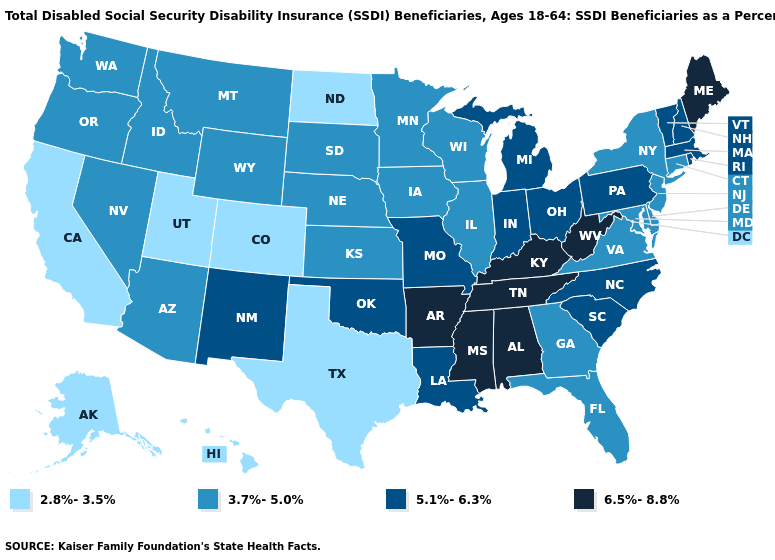What is the value of Minnesota?
Short answer required. 3.7%-5.0%. What is the highest value in the USA?
Quick response, please. 6.5%-8.8%. Does the map have missing data?
Quick response, please. No. Does the map have missing data?
Be succinct. No. Does Texas have the lowest value in the South?
Short answer required. Yes. Which states have the lowest value in the USA?
Write a very short answer. Alaska, California, Colorado, Hawaii, North Dakota, Texas, Utah. What is the value of New York?
Quick response, please. 3.7%-5.0%. Name the states that have a value in the range 6.5%-8.8%?
Be succinct. Alabama, Arkansas, Kentucky, Maine, Mississippi, Tennessee, West Virginia. Name the states that have a value in the range 6.5%-8.8%?
Concise answer only. Alabama, Arkansas, Kentucky, Maine, Mississippi, Tennessee, West Virginia. Does the first symbol in the legend represent the smallest category?
Short answer required. Yes. Does Mississippi have a higher value than Kansas?
Quick response, please. Yes. Name the states that have a value in the range 3.7%-5.0%?
Quick response, please. Arizona, Connecticut, Delaware, Florida, Georgia, Idaho, Illinois, Iowa, Kansas, Maryland, Minnesota, Montana, Nebraska, Nevada, New Jersey, New York, Oregon, South Dakota, Virginia, Washington, Wisconsin, Wyoming. Among the states that border Delaware , does New Jersey have the lowest value?
Quick response, please. Yes. Does Rhode Island have the highest value in the Northeast?
Give a very brief answer. No. 